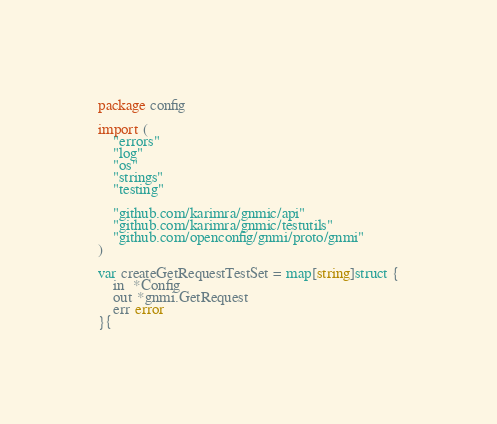Convert code to text. <code><loc_0><loc_0><loc_500><loc_500><_Go_>package config

import (
	"errors"
	"log"
	"os"
	"strings"
	"testing"

	"github.com/karimra/gnmic/api"
	"github.com/karimra/gnmic/testutils"
	"github.com/openconfig/gnmi/proto/gnmi"
)

var createGetRequestTestSet = map[string]struct {
	in  *Config
	out *gnmi.GetRequest
	err error
}{</code> 